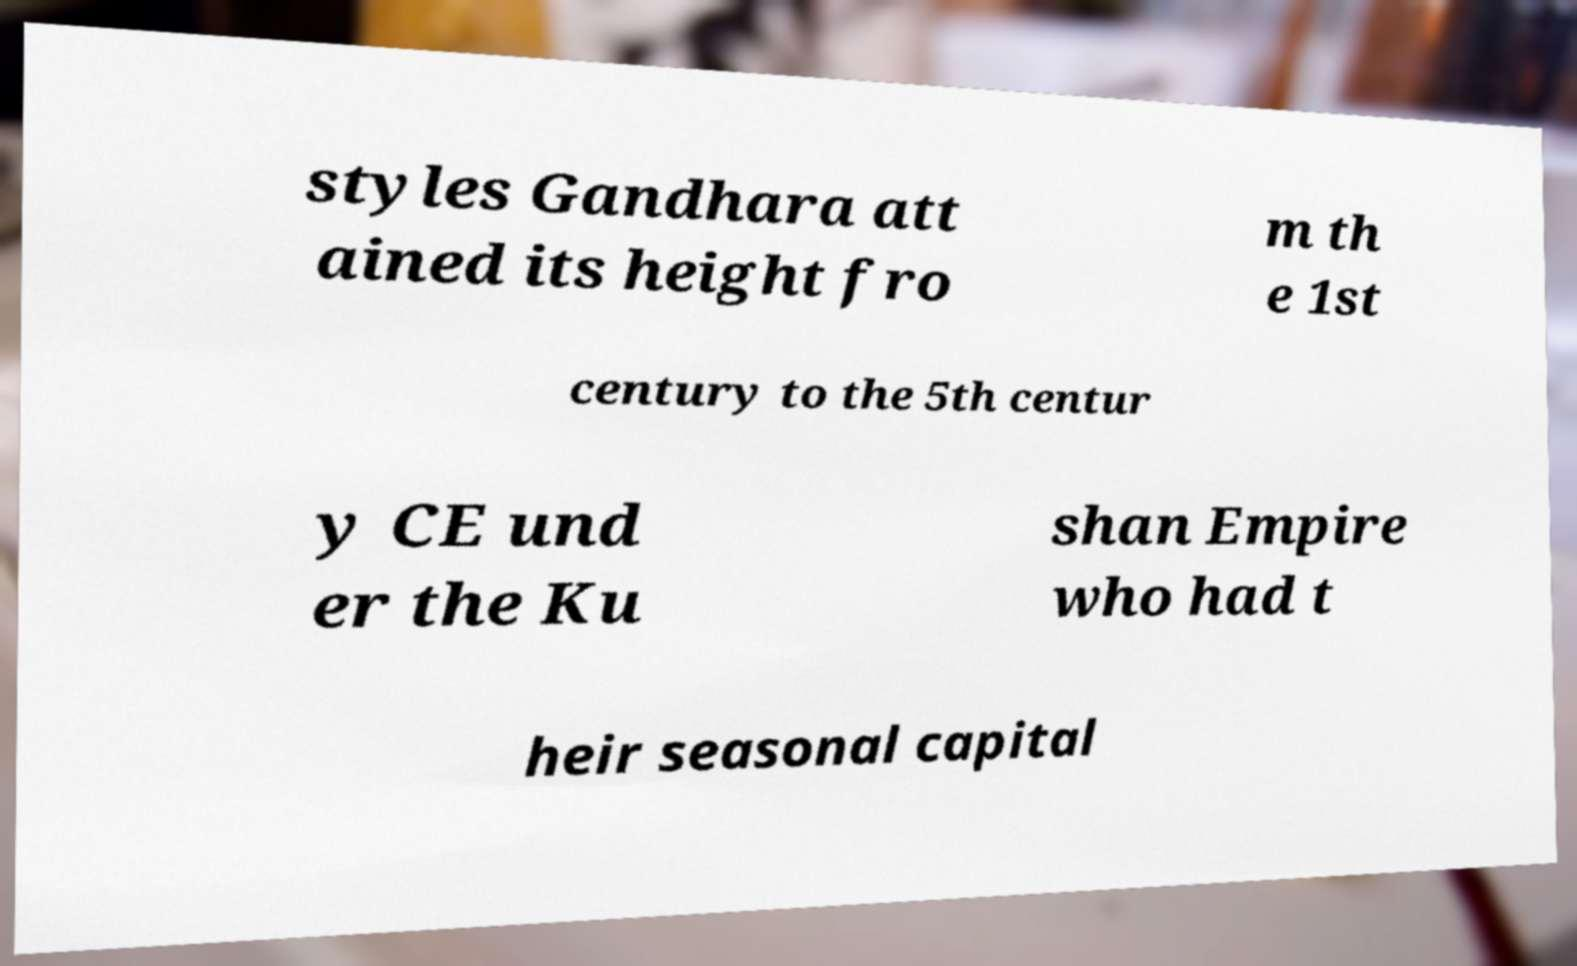There's text embedded in this image that I need extracted. Can you transcribe it verbatim? styles Gandhara att ained its height fro m th e 1st century to the 5th centur y CE und er the Ku shan Empire who had t heir seasonal capital 